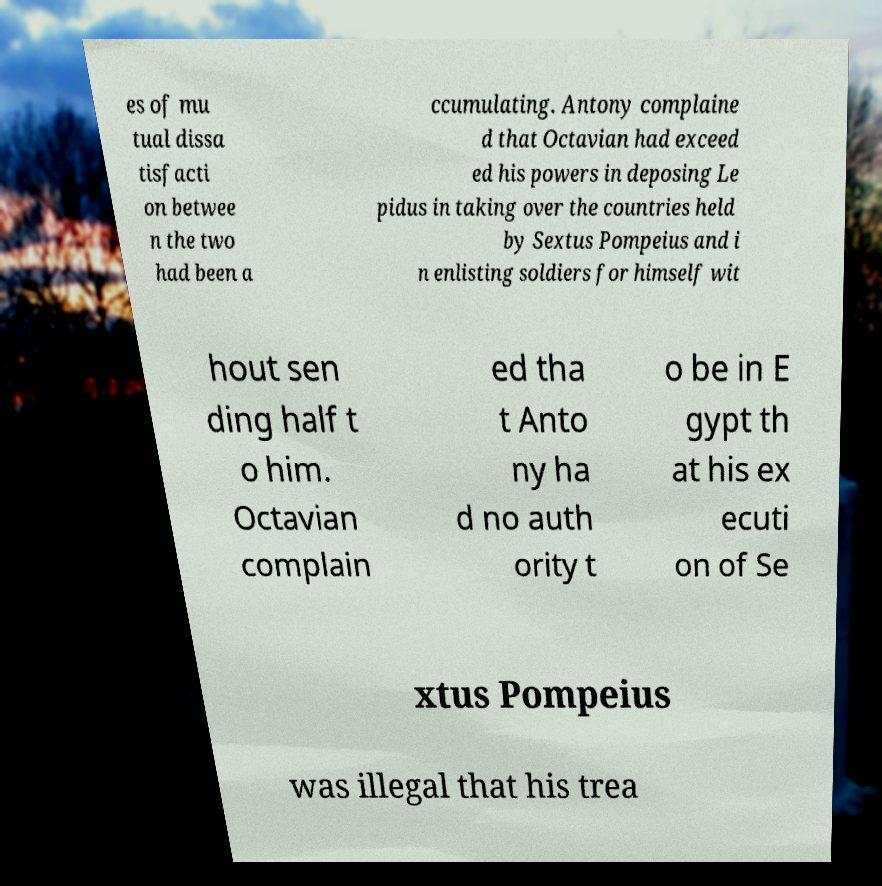Could you assist in decoding the text presented in this image and type it out clearly? es of mu tual dissa tisfacti on betwee n the two had been a ccumulating. Antony complaine d that Octavian had exceed ed his powers in deposing Le pidus in taking over the countries held by Sextus Pompeius and i n enlisting soldiers for himself wit hout sen ding half t o him. Octavian complain ed tha t Anto ny ha d no auth ority t o be in E gypt th at his ex ecuti on of Se xtus Pompeius was illegal that his trea 